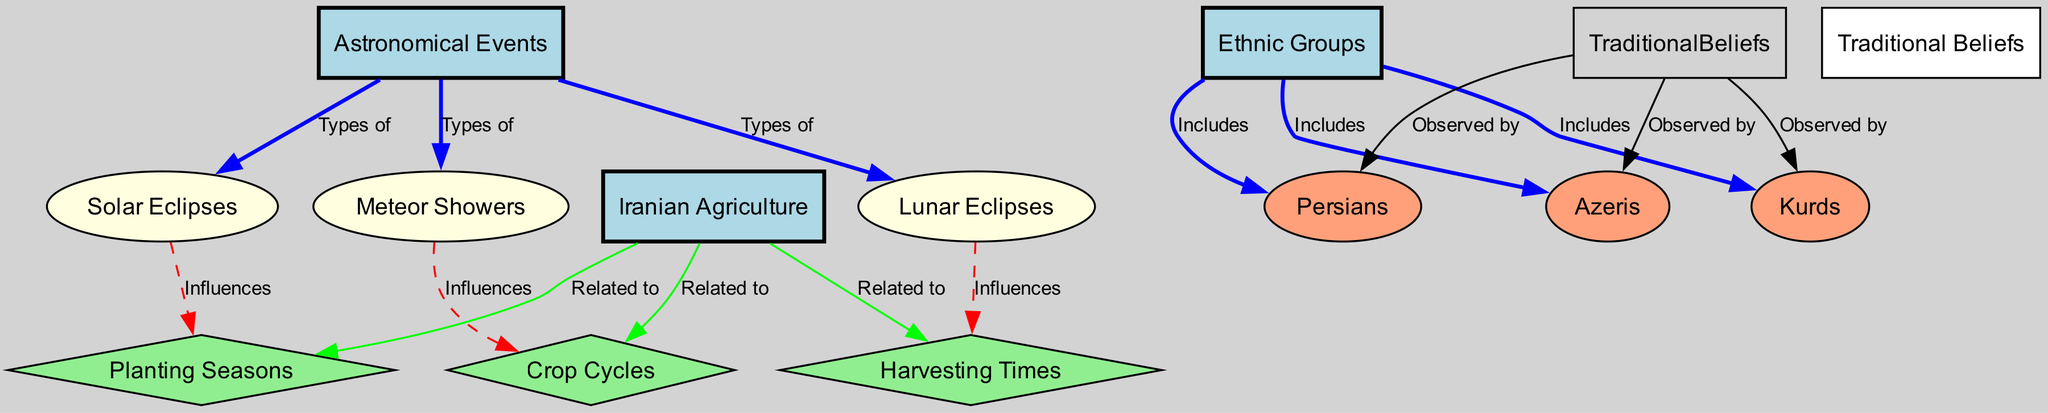What types of astronomical events are listed in the diagram? The diagram lists three types of astronomical events: Solar Eclipses, Lunar Eclipses, and Meteor Showers. They are directly connected to the node "Astronomical Events."
Answer: Solar Eclipses, Lunar Eclipses, Meteor Showers How many ethnic groups are included in the diagram? The diagram includes three ethnic groups: Persians, Kurds, and Azeris, each connected to the node "Ethnic Groups."
Answer: Three Which astronomical event influences the planting seasons? According to the diagram, Solar Eclipses influence the Planting Seasons, as denoted by the dashed red edge leading from Solar Eclipses to Planting Seasons.
Answer: Solar Eclipses What is the relationship between lunar eclipses and harvesting times? The diagram demonstrates that Lunar Eclipses have an influence on Harvesting Times, indicated by a dashed red edge connecting the two nodes.
Answer: Influences How does the diagram categorize the nodes related to agricultural practices? The nodes related to agricultural practices are categorized as Crop Cycles, Planting Seasons, and Harvesting Times. These nodes are represented as diamond shapes in the diagram and are directly related to the "Agriculture" node.
Answer: Crop Cycles, Planting Seasons, Harvesting Times What traditional beliefs are observed by the Kurds? The diagram shows that Kurds observe Traditional Beliefs, as evidenced by the connection from Traditional Beliefs to Kurds. Since the belief is shared, the answer remains as Traditional Beliefs.
Answer: Traditional Beliefs Which ethnic group is influenced by solar eclipses for planting? The influence of Solar Eclipses on planting can primarily affect all ethnic groups; however, the diagram does not specify a unique group as impacted. Therefore, the answer remains nondiscriminant.
Answer: All ethnic groups 